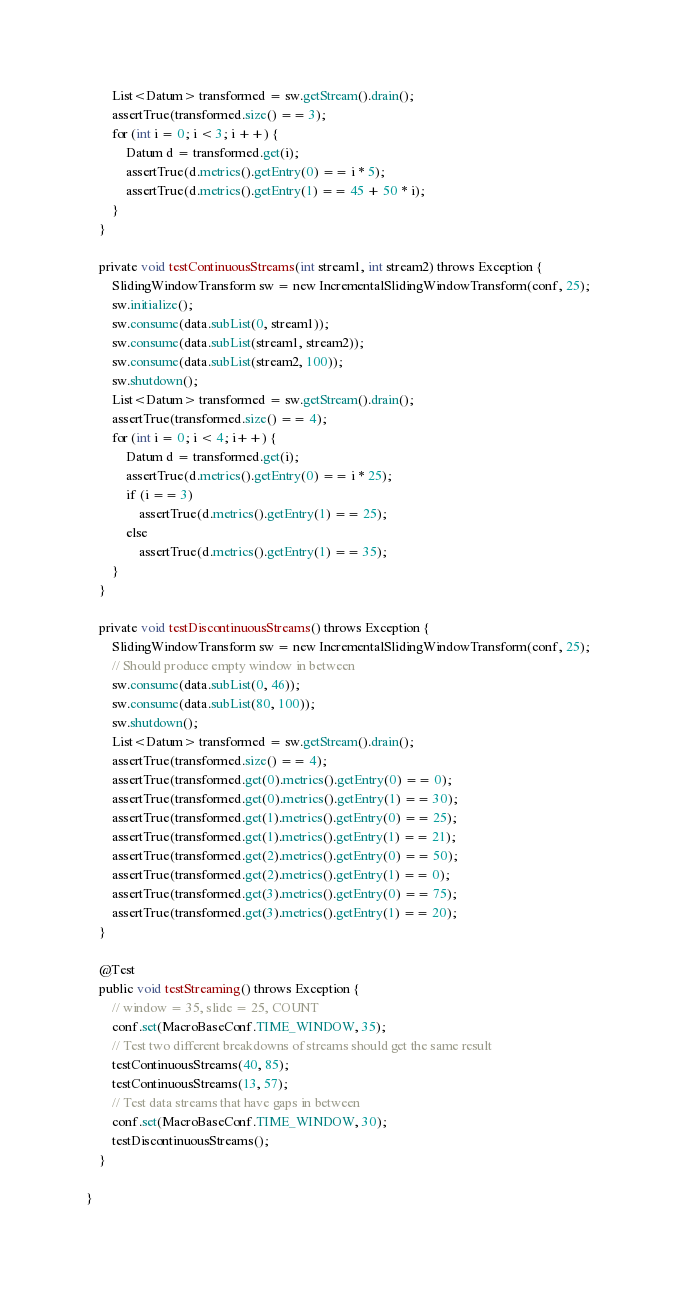<code> <loc_0><loc_0><loc_500><loc_500><_Java_>        List<Datum> transformed = sw.getStream().drain();
        assertTrue(transformed.size() == 3);
        for (int i = 0; i < 3; i ++) {
            Datum d = transformed.get(i);
            assertTrue(d.metrics().getEntry(0) == i * 5);
            assertTrue(d.metrics().getEntry(1) == 45 + 50 * i);
        }
    }

    private void testContinuousStreams(int stream1, int stream2) throws Exception {
        SlidingWindowTransform sw = new IncrementalSlidingWindowTransform(conf, 25);
        sw.initialize();
        sw.consume(data.subList(0, stream1));
        sw.consume(data.subList(stream1, stream2));
        sw.consume(data.subList(stream2, 100));
        sw.shutdown();
        List<Datum> transformed = sw.getStream().drain();
        assertTrue(transformed.size() == 4);
        for (int i = 0; i < 4; i++) {
            Datum d = transformed.get(i);
            assertTrue(d.metrics().getEntry(0) == i * 25);
            if (i == 3)
                assertTrue(d.metrics().getEntry(1) == 25);
            else
                assertTrue(d.metrics().getEntry(1) == 35);
        }
    }

    private void testDiscontinuousStreams() throws Exception {
        SlidingWindowTransform sw = new IncrementalSlidingWindowTransform(conf, 25);
        // Should produce empty window in between
        sw.consume(data.subList(0, 46));
        sw.consume(data.subList(80, 100));
        sw.shutdown();
        List<Datum> transformed = sw.getStream().drain();
        assertTrue(transformed.size() == 4);
        assertTrue(transformed.get(0).metrics().getEntry(0) == 0);
        assertTrue(transformed.get(0).metrics().getEntry(1) == 30);
        assertTrue(transformed.get(1).metrics().getEntry(0) == 25);
        assertTrue(transformed.get(1).metrics().getEntry(1) == 21);
        assertTrue(transformed.get(2).metrics().getEntry(0) == 50);
        assertTrue(transformed.get(2).metrics().getEntry(1) == 0);
        assertTrue(transformed.get(3).metrics().getEntry(0) == 75);
        assertTrue(transformed.get(3).metrics().getEntry(1) == 20);
    }

    @Test
    public void testStreaming() throws Exception {
        // window = 35, slide = 25, COUNT
        conf.set(MacroBaseConf.TIME_WINDOW, 35);
        // Test two different breakdowns of streams should get the same result
        testContinuousStreams(40, 85);
        testContinuousStreams(13, 57);
        // Test data streams that have gaps in between
        conf.set(MacroBaseConf.TIME_WINDOW, 30);
        testDiscontinuousStreams();
    }

}
</code> 